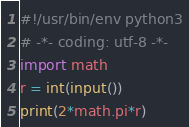<code> <loc_0><loc_0><loc_500><loc_500><_Python_>#!/usr/bin/env python3
# -*- coding: utf-8 -*-
import math
r = int(input())
print(2*math.pi*r)</code> 